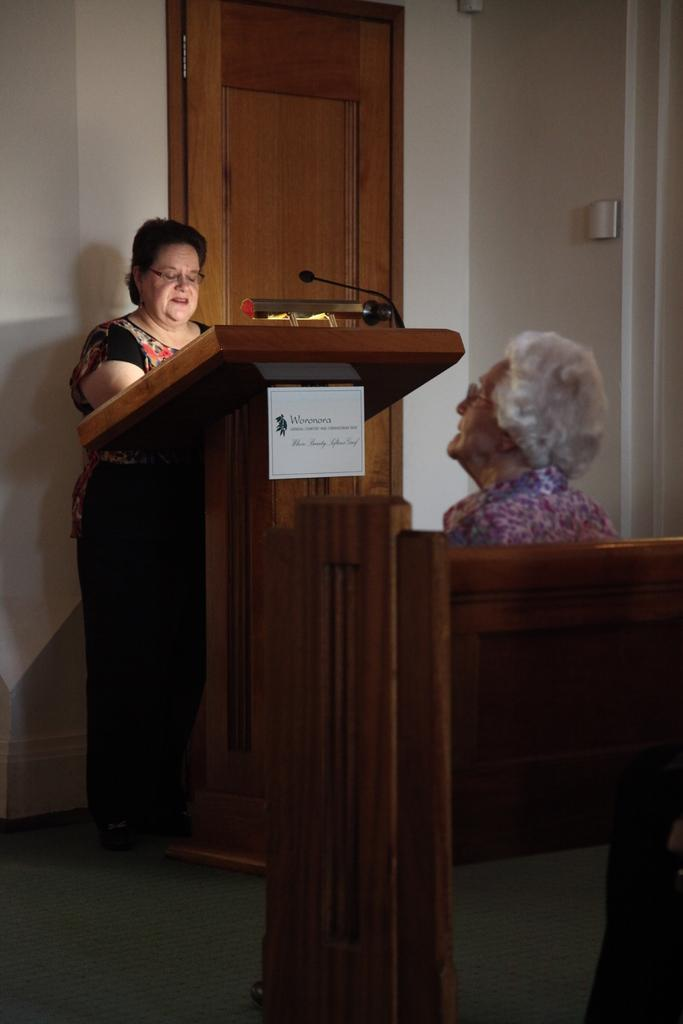What is the main subject of the image? The main subject of the image is a woman standing in front of a wooden stand. What is on the wooden stand? A mic is placed on the wooden stand. Are there any other people in the image? Yes, there is another woman sitting in the right corner of the image. How many children are taking a bath in the image? There are no children or baths present in the image. What type of judge is sitting next to the woman in the image? There is no judge present in the image; only two women are visible. 